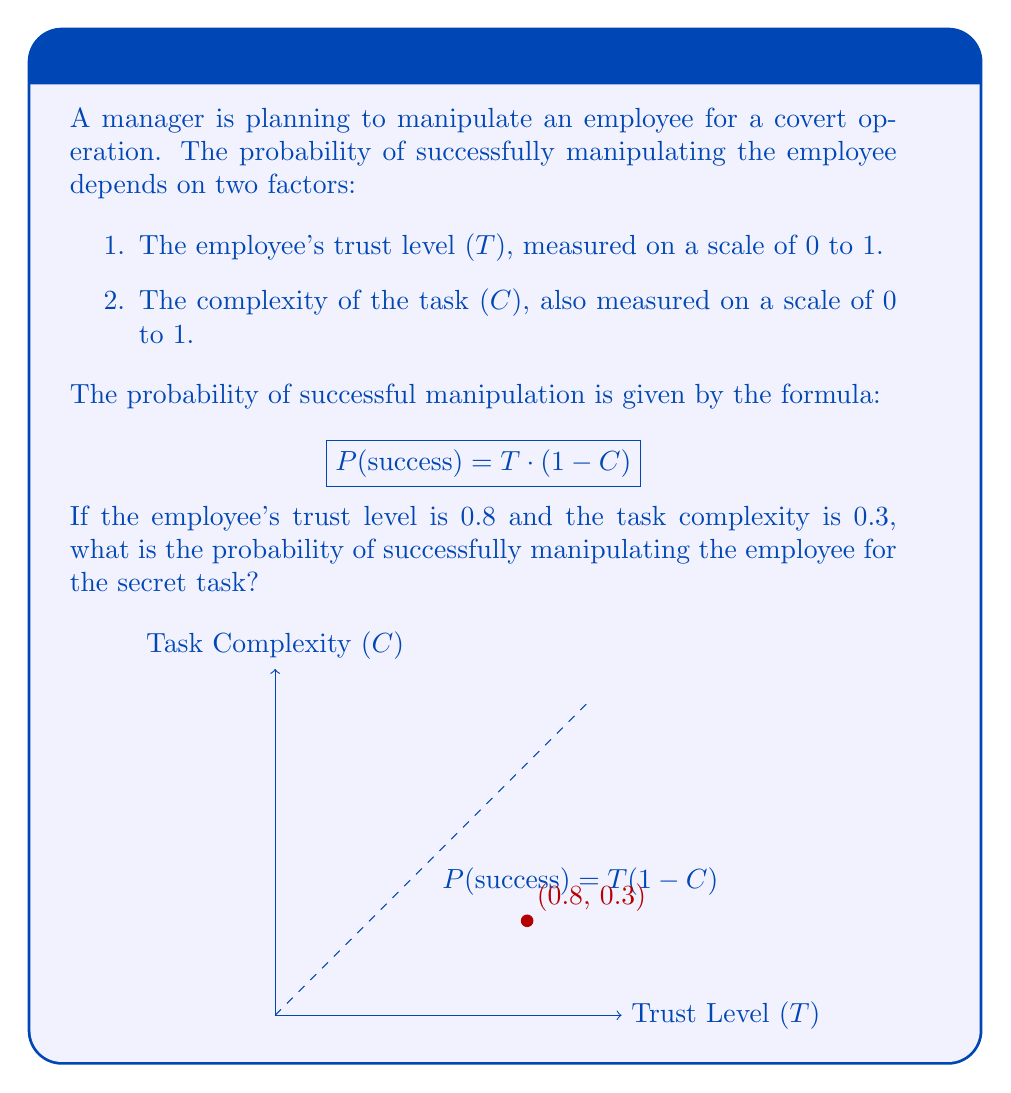Can you solve this math problem? To solve this problem, we'll follow these steps:

1. Identify the given values:
   Trust level (T) = 0.8
   Task complexity (C) = 0.3

2. Apply the formula for the probability of successful manipulation:
   $$P(\text{success}) = T \cdot (1 - C)$$

3. Substitute the values into the formula:
   $$P(\text{success}) = 0.8 \cdot (1 - 0.3)$$

4. Simplify the expression inside the parentheses:
   $$P(\text{success}) = 0.8 \cdot 0.7$$

5. Multiply the numbers:
   $$P(\text{success}) = 0.56$$

6. Convert the decimal to a percentage:
   $$P(\text{success}) = 56\%$$

Therefore, the probability of successfully manipulating the employee for the secret task is 0.56 or 56%.
Answer: $0.56$ or $56\%$ 